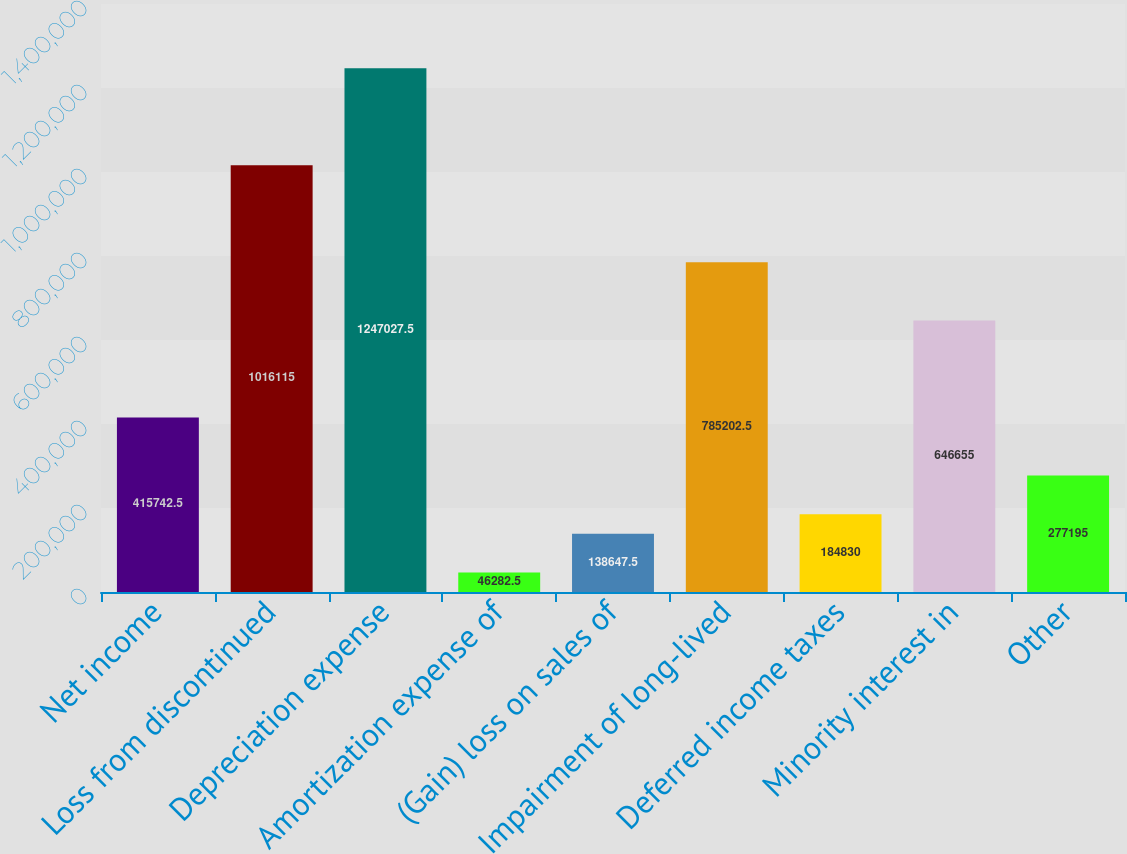<chart> <loc_0><loc_0><loc_500><loc_500><bar_chart><fcel>Net income<fcel>Loss from discontinued<fcel>Depreciation expense<fcel>Amortization expense of<fcel>(Gain) loss on sales of<fcel>Impairment of long-lived<fcel>Deferred income taxes<fcel>Minority interest in<fcel>Other<nl><fcel>415742<fcel>1.01612e+06<fcel>1.24703e+06<fcel>46282.5<fcel>138648<fcel>785202<fcel>184830<fcel>646655<fcel>277195<nl></chart> 